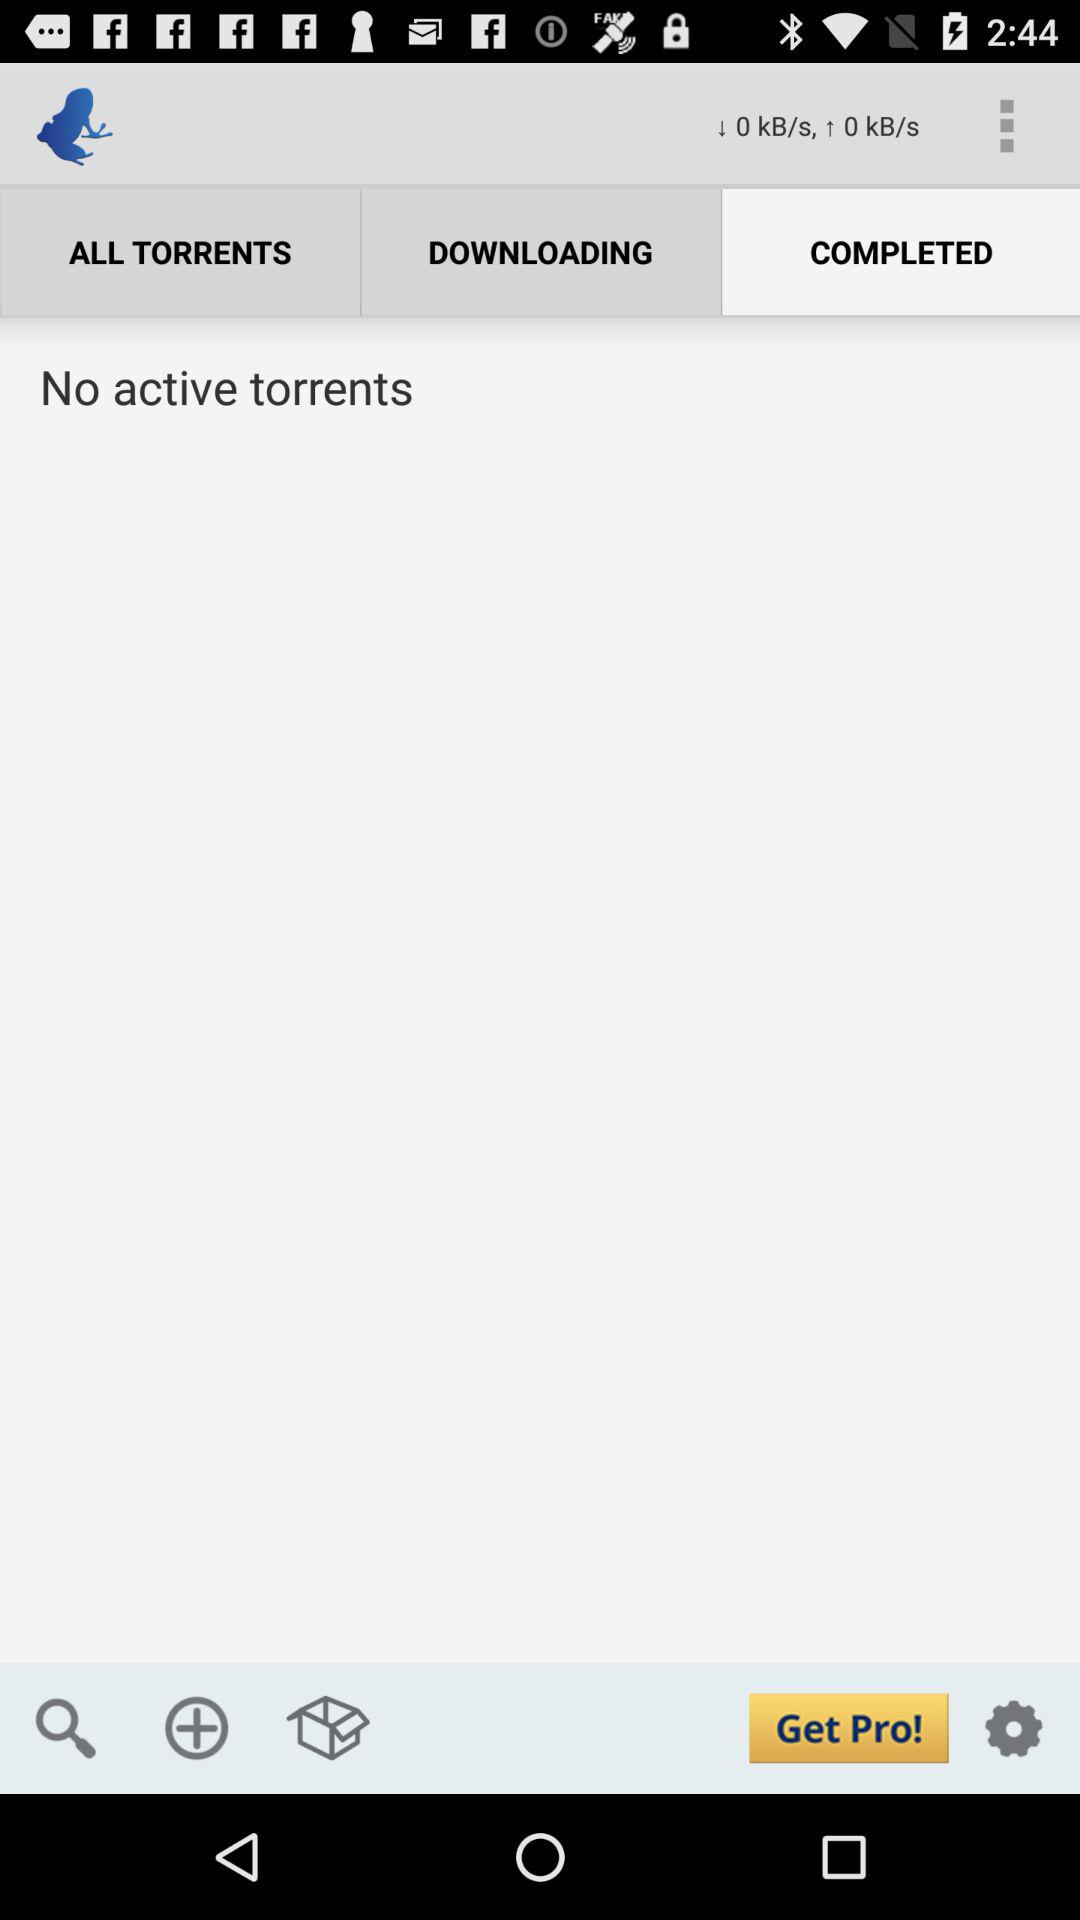Are there any ongoing downloads indicated in this view? No, there are no ongoing downloads. The screen reads 'No active torrents', indicating that all downloads have either been completed or none have been started yet. 